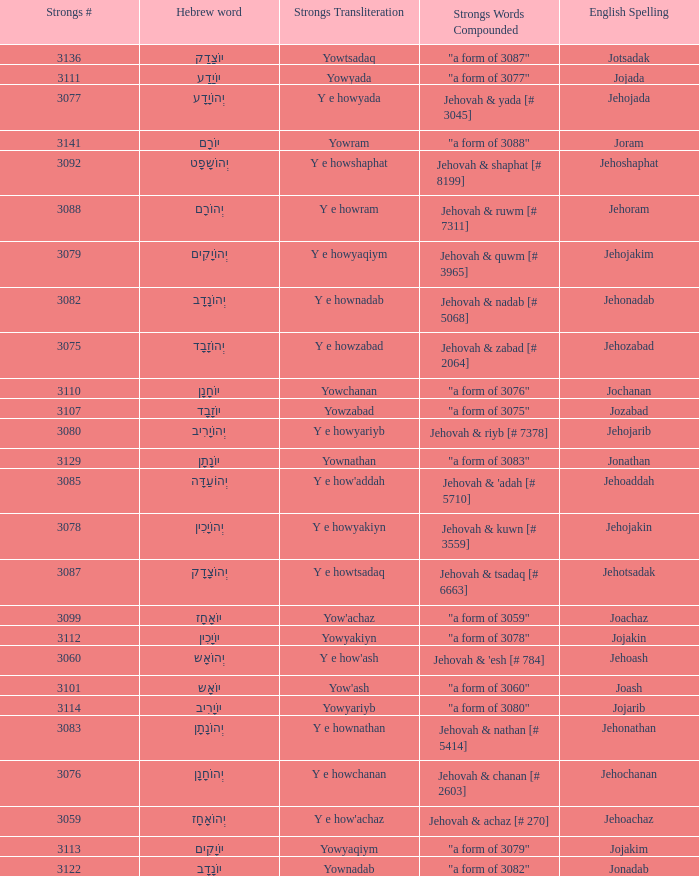What is the strongs transliteration of the hebrew word יוֹחָנָן? Yowchanan. 